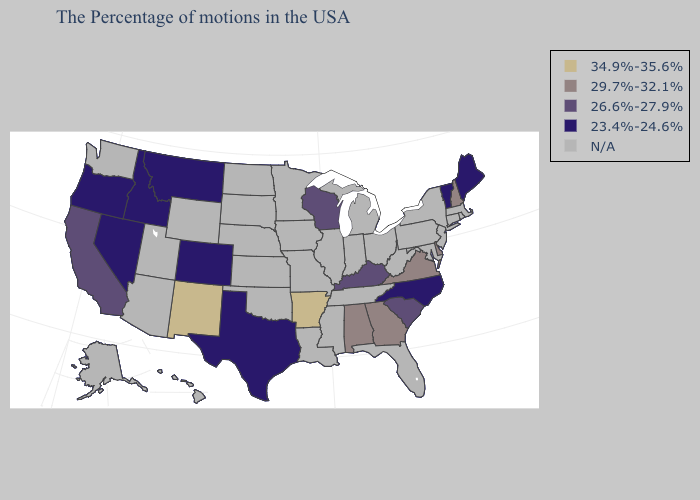What is the highest value in the South ?
Concise answer only. 34.9%-35.6%. Does the map have missing data?
Write a very short answer. Yes. What is the lowest value in states that border Montana?
Keep it brief. 23.4%-24.6%. Name the states that have a value in the range N/A?
Write a very short answer. Massachusetts, Rhode Island, Connecticut, New York, New Jersey, Maryland, Pennsylvania, West Virginia, Ohio, Florida, Michigan, Indiana, Tennessee, Illinois, Mississippi, Louisiana, Missouri, Minnesota, Iowa, Kansas, Nebraska, Oklahoma, South Dakota, North Dakota, Wyoming, Utah, Arizona, Washington, Alaska, Hawaii. What is the highest value in the MidWest ?
Short answer required. 26.6%-27.9%. What is the value of Florida?
Keep it brief. N/A. Does the first symbol in the legend represent the smallest category?
Be succinct. No. Does Georgia have the lowest value in the USA?
Concise answer only. No. What is the value of Georgia?
Answer briefly. 29.7%-32.1%. Does New Hampshire have the lowest value in the Northeast?
Keep it brief. No. Does New Mexico have the highest value in the USA?
Short answer required. Yes. Is the legend a continuous bar?
Keep it brief. No. Does the map have missing data?
Quick response, please. Yes. 